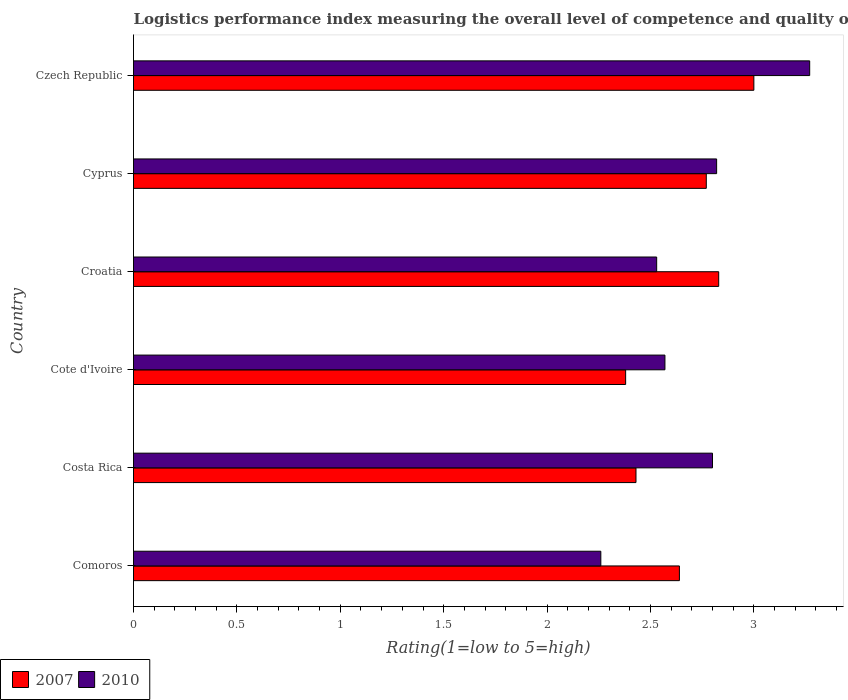How many different coloured bars are there?
Provide a succinct answer. 2. How many groups of bars are there?
Your answer should be very brief. 6. Are the number of bars on each tick of the Y-axis equal?
Your answer should be very brief. Yes. How many bars are there on the 5th tick from the bottom?
Ensure brevity in your answer.  2. What is the label of the 5th group of bars from the top?
Make the answer very short. Costa Rica. What is the Logistic performance index in 2007 in Comoros?
Make the answer very short. 2.64. Across all countries, what is the maximum Logistic performance index in 2010?
Make the answer very short. 3.27. Across all countries, what is the minimum Logistic performance index in 2010?
Offer a terse response. 2.26. In which country was the Logistic performance index in 2010 maximum?
Provide a short and direct response. Czech Republic. In which country was the Logistic performance index in 2007 minimum?
Give a very brief answer. Cote d'Ivoire. What is the total Logistic performance index in 2010 in the graph?
Keep it short and to the point. 16.25. What is the difference between the Logistic performance index in 2007 in Comoros and that in Czech Republic?
Offer a terse response. -0.36. What is the difference between the Logistic performance index in 2010 in Comoros and the Logistic performance index in 2007 in Cote d'Ivoire?
Keep it short and to the point. -0.12. What is the average Logistic performance index in 2010 per country?
Your answer should be compact. 2.71. What is the difference between the Logistic performance index in 2007 and Logistic performance index in 2010 in Costa Rica?
Your response must be concise. -0.37. What is the ratio of the Logistic performance index in 2010 in Costa Rica to that in Cyprus?
Offer a very short reply. 0.99. Is the Logistic performance index in 2010 in Croatia less than that in Cyprus?
Provide a succinct answer. Yes. What is the difference between the highest and the second highest Logistic performance index in 2010?
Your answer should be very brief. 0.45. What is the difference between the highest and the lowest Logistic performance index in 2010?
Offer a terse response. 1.01. In how many countries, is the Logistic performance index in 2010 greater than the average Logistic performance index in 2010 taken over all countries?
Your answer should be very brief. 3. What does the 2nd bar from the top in Comoros represents?
Your answer should be very brief. 2007. What does the 2nd bar from the bottom in Cyprus represents?
Your response must be concise. 2010. How many bars are there?
Give a very brief answer. 12. What is the difference between two consecutive major ticks on the X-axis?
Your answer should be compact. 0.5. Does the graph contain any zero values?
Give a very brief answer. No. Where does the legend appear in the graph?
Offer a very short reply. Bottom left. How many legend labels are there?
Provide a short and direct response. 2. What is the title of the graph?
Ensure brevity in your answer.  Logistics performance index measuring the overall level of competence and quality of logistics services. Does "1974" appear as one of the legend labels in the graph?
Make the answer very short. No. What is the label or title of the X-axis?
Offer a terse response. Rating(1=low to 5=high). What is the Rating(1=low to 5=high) in 2007 in Comoros?
Provide a short and direct response. 2.64. What is the Rating(1=low to 5=high) of 2010 in Comoros?
Your answer should be compact. 2.26. What is the Rating(1=low to 5=high) in 2007 in Costa Rica?
Provide a succinct answer. 2.43. What is the Rating(1=low to 5=high) in 2010 in Costa Rica?
Keep it short and to the point. 2.8. What is the Rating(1=low to 5=high) in 2007 in Cote d'Ivoire?
Your answer should be compact. 2.38. What is the Rating(1=low to 5=high) in 2010 in Cote d'Ivoire?
Give a very brief answer. 2.57. What is the Rating(1=low to 5=high) of 2007 in Croatia?
Your answer should be compact. 2.83. What is the Rating(1=low to 5=high) of 2010 in Croatia?
Offer a terse response. 2.53. What is the Rating(1=low to 5=high) in 2007 in Cyprus?
Make the answer very short. 2.77. What is the Rating(1=low to 5=high) in 2010 in Cyprus?
Your answer should be compact. 2.82. What is the Rating(1=low to 5=high) in 2007 in Czech Republic?
Provide a short and direct response. 3. What is the Rating(1=low to 5=high) of 2010 in Czech Republic?
Make the answer very short. 3.27. Across all countries, what is the maximum Rating(1=low to 5=high) of 2010?
Provide a succinct answer. 3.27. Across all countries, what is the minimum Rating(1=low to 5=high) in 2007?
Make the answer very short. 2.38. Across all countries, what is the minimum Rating(1=low to 5=high) of 2010?
Your answer should be very brief. 2.26. What is the total Rating(1=low to 5=high) of 2007 in the graph?
Your answer should be very brief. 16.05. What is the total Rating(1=low to 5=high) in 2010 in the graph?
Your answer should be very brief. 16.25. What is the difference between the Rating(1=low to 5=high) of 2007 in Comoros and that in Costa Rica?
Your response must be concise. 0.21. What is the difference between the Rating(1=low to 5=high) of 2010 in Comoros and that in Costa Rica?
Ensure brevity in your answer.  -0.54. What is the difference between the Rating(1=low to 5=high) of 2007 in Comoros and that in Cote d'Ivoire?
Ensure brevity in your answer.  0.26. What is the difference between the Rating(1=low to 5=high) of 2010 in Comoros and that in Cote d'Ivoire?
Give a very brief answer. -0.31. What is the difference between the Rating(1=low to 5=high) in 2007 in Comoros and that in Croatia?
Provide a short and direct response. -0.19. What is the difference between the Rating(1=low to 5=high) of 2010 in Comoros and that in Croatia?
Offer a terse response. -0.27. What is the difference between the Rating(1=low to 5=high) in 2007 in Comoros and that in Cyprus?
Provide a short and direct response. -0.13. What is the difference between the Rating(1=low to 5=high) in 2010 in Comoros and that in Cyprus?
Keep it short and to the point. -0.56. What is the difference between the Rating(1=low to 5=high) in 2007 in Comoros and that in Czech Republic?
Give a very brief answer. -0.36. What is the difference between the Rating(1=low to 5=high) of 2010 in Comoros and that in Czech Republic?
Provide a succinct answer. -1.01. What is the difference between the Rating(1=low to 5=high) in 2010 in Costa Rica and that in Cote d'Ivoire?
Provide a succinct answer. 0.23. What is the difference between the Rating(1=low to 5=high) in 2010 in Costa Rica and that in Croatia?
Your answer should be very brief. 0.27. What is the difference between the Rating(1=low to 5=high) in 2007 in Costa Rica and that in Cyprus?
Give a very brief answer. -0.34. What is the difference between the Rating(1=low to 5=high) in 2010 in Costa Rica and that in Cyprus?
Give a very brief answer. -0.02. What is the difference between the Rating(1=low to 5=high) in 2007 in Costa Rica and that in Czech Republic?
Offer a very short reply. -0.57. What is the difference between the Rating(1=low to 5=high) in 2010 in Costa Rica and that in Czech Republic?
Provide a succinct answer. -0.47. What is the difference between the Rating(1=low to 5=high) of 2007 in Cote d'Ivoire and that in Croatia?
Offer a terse response. -0.45. What is the difference between the Rating(1=low to 5=high) of 2007 in Cote d'Ivoire and that in Cyprus?
Ensure brevity in your answer.  -0.39. What is the difference between the Rating(1=low to 5=high) in 2007 in Cote d'Ivoire and that in Czech Republic?
Provide a short and direct response. -0.62. What is the difference between the Rating(1=low to 5=high) in 2010 in Cote d'Ivoire and that in Czech Republic?
Give a very brief answer. -0.7. What is the difference between the Rating(1=low to 5=high) in 2010 in Croatia and that in Cyprus?
Your answer should be very brief. -0.29. What is the difference between the Rating(1=low to 5=high) in 2007 in Croatia and that in Czech Republic?
Provide a succinct answer. -0.17. What is the difference between the Rating(1=low to 5=high) in 2010 in Croatia and that in Czech Republic?
Your answer should be compact. -0.74. What is the difference between the Rating(1=low to 5=high) in 2007 in Cyprus and that in Czech Republic?
Your answer should be very brief. -0.23. What is the difference between the Rating(1=low to 5=high) of 2010 in Cyprus and that in Czech Republic?
Ensure brevity in your answer.  -0.45. What is the difference between the Rating(1=low to 5=high) in 2007 in Comoros and the Rating(1=low to 5=high) in 2010 in Costa Rica?
Make the answer very short. -0.16. What is the difference between the Rating(1=low to 5=high) in 2007 in Comoros and the Rating(1=low to 5=high) in 2010 in Cote d'Ivoire?
Give a very brief answer. 0.07. What is the difference between the Rating(1=low to 5=high) of 2007 in Comoros and the Rating(1=low to 5=high) of 2010 in Croatia?
Your answer should be very brief. 0.11. What is the difference between the Rating(1=low to 5=high) in 2007 in Comoros and the Rating(1=low to 5=high) in 2010 in Cyprus?
Offer a terse response. -0.18. What is the difference between the Rating(1=low to 5=high) in 2007 in Comoros and the Rating(1=low to 5=high) in 2010 in Czech Republic?
Your response must be concise. -0.63. What is the difference between the Rating(1=low to 5=high) of 2007 in Costa Rica and the Rating(1=low to 5=high) of 2010 in Cote d'Ivoire?
Provide a short and direct response. -0.14. What is the difference between the Rating(1=low to 5=high) of 2007 in Costa Rica and the Rating(1=low to 5=high) of 2010 in Croatia?
Your answer should be very brief. -0.1. What is the difference between the Rating(1=low to 5=high) in 2007 in Costa Rica and the Rating(1=low to 5=high) in 2010 in Cyprus?
Make the answer very short. -0.39. What is the difference between the Rating(1=low to 5=high) of 2007 in Costa Rica and the Rating(1=low to 5=high) of 2010 in Czech Republic?
Provide a succinct answer. -0.84. What is the difference between the Rating(1=low to 5=high) of 2007 in Cote d'Ivoire and the Rating(1=low to 5=high) of 2010 in Croatia?
Give a very brief answer. -0.15. What is the difference between the Rating(1=low to 5=high) of 2007 in Cote d'Ivoire and the Rating(1=low to 5=high) of 2010 in Cyprus?
Keep it short and to the point. -0.44. What is the difference between the Rating(1=low to 5=high) in 2007 in Cote d'Ivoire and the Rating(1=low to 5=high) in 2010 in Czech Republic?
Ensure brevity in your answer.  -0.89. What is the difference between the Rating(1=low to 5=high) of 2007 in Croatia and the Rating(1=low to 5=high) of 2010 in Czech Republic?
Provide a short and direct response. -0.44. What is the difference between the Rating(1=low to 5=high) in 2007 in Cyprus and the Rating(1=low to 5=high) in 2010 in Czech Republic?
Offer a very short reply. -0.5. What is the average Rating(1=low to 5=high) of 2007 per country?
Your answer should be very brief. 2.67. What is the average Rating(1=low to 5=high) of 2010 per country?
Your answer should be very brief. 2.71. What is the difference between the Rating(1=low to 5=high) in 2007 and Rating(1=low to 5=high) in 2010 in Comoros?
Offer a very short reply. 0.38. What is the difference between the Rating(1=low to 5=high) in 2007 and Rating(1=low to 5=high) in 2010 in Costa Rica?
Provide a succinct answer. -0.37. What is the difference between the Rating(1=low to 5=high) in 2007 and Rating(1=low to 5=high) in 2010 in Cote d'Ivoire?
Your answer should be compact. -0.19. What is the difference between the Rating(1=low to 5=high) of 2007 and Rating(1=low to 5=high) of 2010 in Czech Republic?
Offer a very short reply. -0.27. What is the ratio of the Rating(1=low to 5=high) in 2007 in Comoros to that in Costa Rica?
Your answer should be very brief. 1.09. What is the ratio of the Rating(1=low to 5=high) of 2010 in Comoros to that in Costa Rica?
Offer a terse response. 0.81. What is the ratio of the Rating(1=low to 5=high) in 2007 in Comoros to that in Cote d'Ivoire?
Your response must be concise. 1.11. What is the ratio of the Rating(1=low to 5=high) in 2010 in Comoros to that in Cote d'Ivoire?
Keep it short and to the point. 0.88. What is the ratio of the Rating(1=low to 5=high) of 2007 in Comoros to that in Croatia?
Give a very brief answer. 0.93. What is the ratio of the Rating(1=low to 5=high) in 2010 in Comoros to that in Croatia?
Keep it short and to the point. 0.89. What is the ratio of the Rating(1=low to 5=high) in 2007 in Comoros to that in Cyprus?
Give a very brief answer. 0.95. What is the ratio of the Rating(1=low to 5=high) of 2010 in Comoros to that in Cyprus?
Offer a very short reply. 0.8. What is the ratio of the Rating(1=low to 5=high) in 2010 in Comoros to that in Czech Republic?
Give a very brief answer. 0.69. What is the ratio of the Rating(1=low to 5=high) in 2007 in Costa Rica to that in Cote d'Ivoire?
Your answer should be compact. 1.02. What is the ratio of the Rating(1=low to 5=high) of 2010 in Costa Rica to that in Cote d'Ivoire?
Provide a short and direct response. 1.09. What is the ratio of the Rating(1=low to 5=high) of 2007 in Costa Rica to that in Croatia?
Offer a terse response. 0.86. What is the ratio of the Rating(1=low to 5=high) in 2010 in Costa Rica to that in Croatia?
Your answer should be compact. 1.11. What is the ratio of the Rating(1=low to 5=high) in 2007 in Costa Rica to that in Cyprus?
Your answer should be compact. 0.88. What is the ratio of the Rating(1=low to 5=high) in 2010 in Costa Rica to that in Cyprus?
Offer a very short reply. 0.99. What is the ratio of the Rating(1=low to 5=high) of 2007 in Costa Rica to that in Czech Republic?
Provide a short and direct response. 0.81. What is the ratio of the Rating(1=low to 5=high) of 2010 in Costa Rica to that in Czech Republic?
Give a very brief answer. 0.86. What is the ratio of the Rating(1=low to 5=high) of 2007 in Cote d'Ivoire to that in Croatia?
Ensure brevity in your answer.  0.84. What is the ratio of the Rating(1=low to 5=high) of 2010 in Cote d'Ivoire to that in Croatia?
Offer a very short reply. 1.02. What is the ratio of the Rating(1=low to 5=high) of 2007 in Cote d'Ivoire to that in Cyprus?
Give a very brief answer. 0.86. What is the ratio of the Rating(1=low to 5=high) of 2010 in Cote d'Ivoire to that in Cyprus?
Ensure brevity in your answer.  0.91. What is the ratio of the Rating(1=low to 5=high) in 2007 in Cote d'Ivoire to that in Czech Republic?
Offer a very short reply. 0.79. What is the ratio of the Rating(1=low to 5=high) of 2010 in Cote d'Ivoire to that in Czech Republic?
Offer a very short reply. 0.79. What is the ratio of the Rating(1=low to 5=high) of 2007 in Croatia to that in Cyprus?
Make the answer very short. 1.02. What is the ratio of the Rating(1=low to 5=high) of 2010 in Croatia to that in Cyprus?
Your response must be concise. 0.9. What is the ratio of the Rating(1=low to 5=high) of 2007 in Croatia to that in Czech Republic?
Give a very brief answer. 0.94. What is the ratio of the Rating(1=low to 5=high) of 2010 in Croatia to that in Czech Republic?
Your response must be concise. 0.77. What is the ratio of the Rating(1=low to 5=high) in 2007 in Cyprus to that in Czech Republic?
Offer a very short reply. 0.92. What is the ratio of the Rating(1=low to 5=high) in 2010 in Cyprus to that in Czech Republic?
Keep it short and to the point. 0.86. What is the difference between the highest and the second highest Rating(1=low to 5=high) of 2007?
Keep it short and to the point. 0.17. What is the difference between the highest and the second highest Rating(1=low to 5=high) in 2010?
Offer a terse response. 0.45. What is the difference between the highest and the lowest Rating(1=low to 5=high) in 2007?
Offer a terse response. 0.62. What is the difference between the highest and the lowest Rating(1=low to 5=high) in 2010?
Your response must be concise. 1.01. 